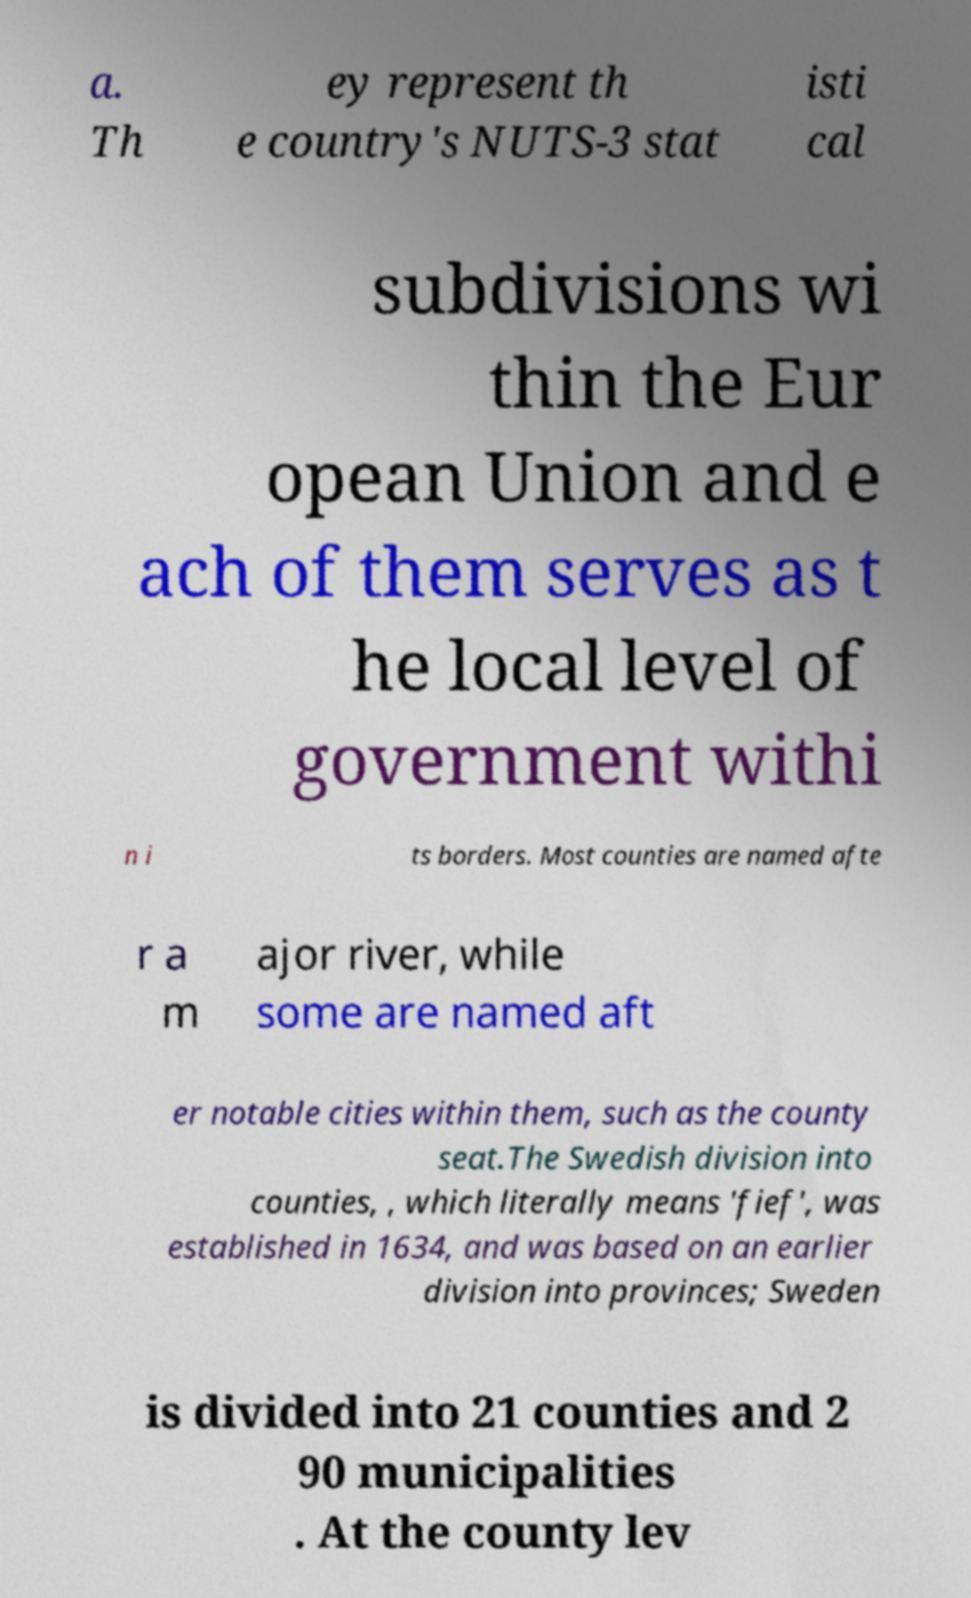Could you extract and type out the text from this image? a. Th ey represent th e country's NUTS-3 stat isti cal subdivisions wi thin the Eur opean Union and e ach of them serves as t he local level of government withi n i ts borders. Most counties are named afte r a m ajor river, while some are named aft er notable cities within them, such as the county seat.The Swedish division into counties, , which literally means 'fief', was established in 1634, and was based on an earlier division into provinces; Sweden is divided into 21 counties and 2 90 municipalities . At the county lev 